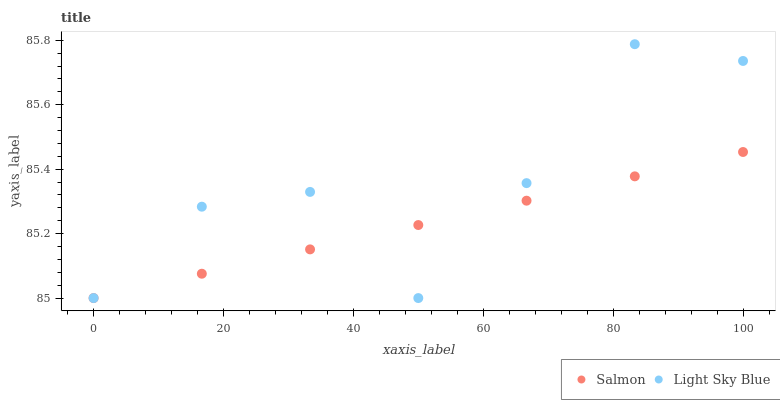Does Salmon have the minimum area under the curve?
Answer yes or no. Yes. Does Light Sky Blue have the maximum area under the curve?
Answer yes or no. Yes. Does Salmon have the maximum area under the curve?
Answer yes or no. No. Is Salmon the smoothest?
Answer yes or no. Yes. Is Light Sky Blue the roughest?
Answer yes or no. Yes. Is Salmon the roughest?
Answer yes or no. No. Does Light Sky Blue have the lowest value?
Answer yes or no. Yes. Does Light Sky Blue have the highest value?
Answer yes or no. Yes. Does Salmon have the highest value?
Answer yes or no. No. Does Light Sky Blue intersect Salmon?
Answer yes or no. Yes. Is Light Sky Blue less than Salmon?
Answer yes or no. No. Is Light Sky Blue greater than Salmon?
Answer yes or no. No. 